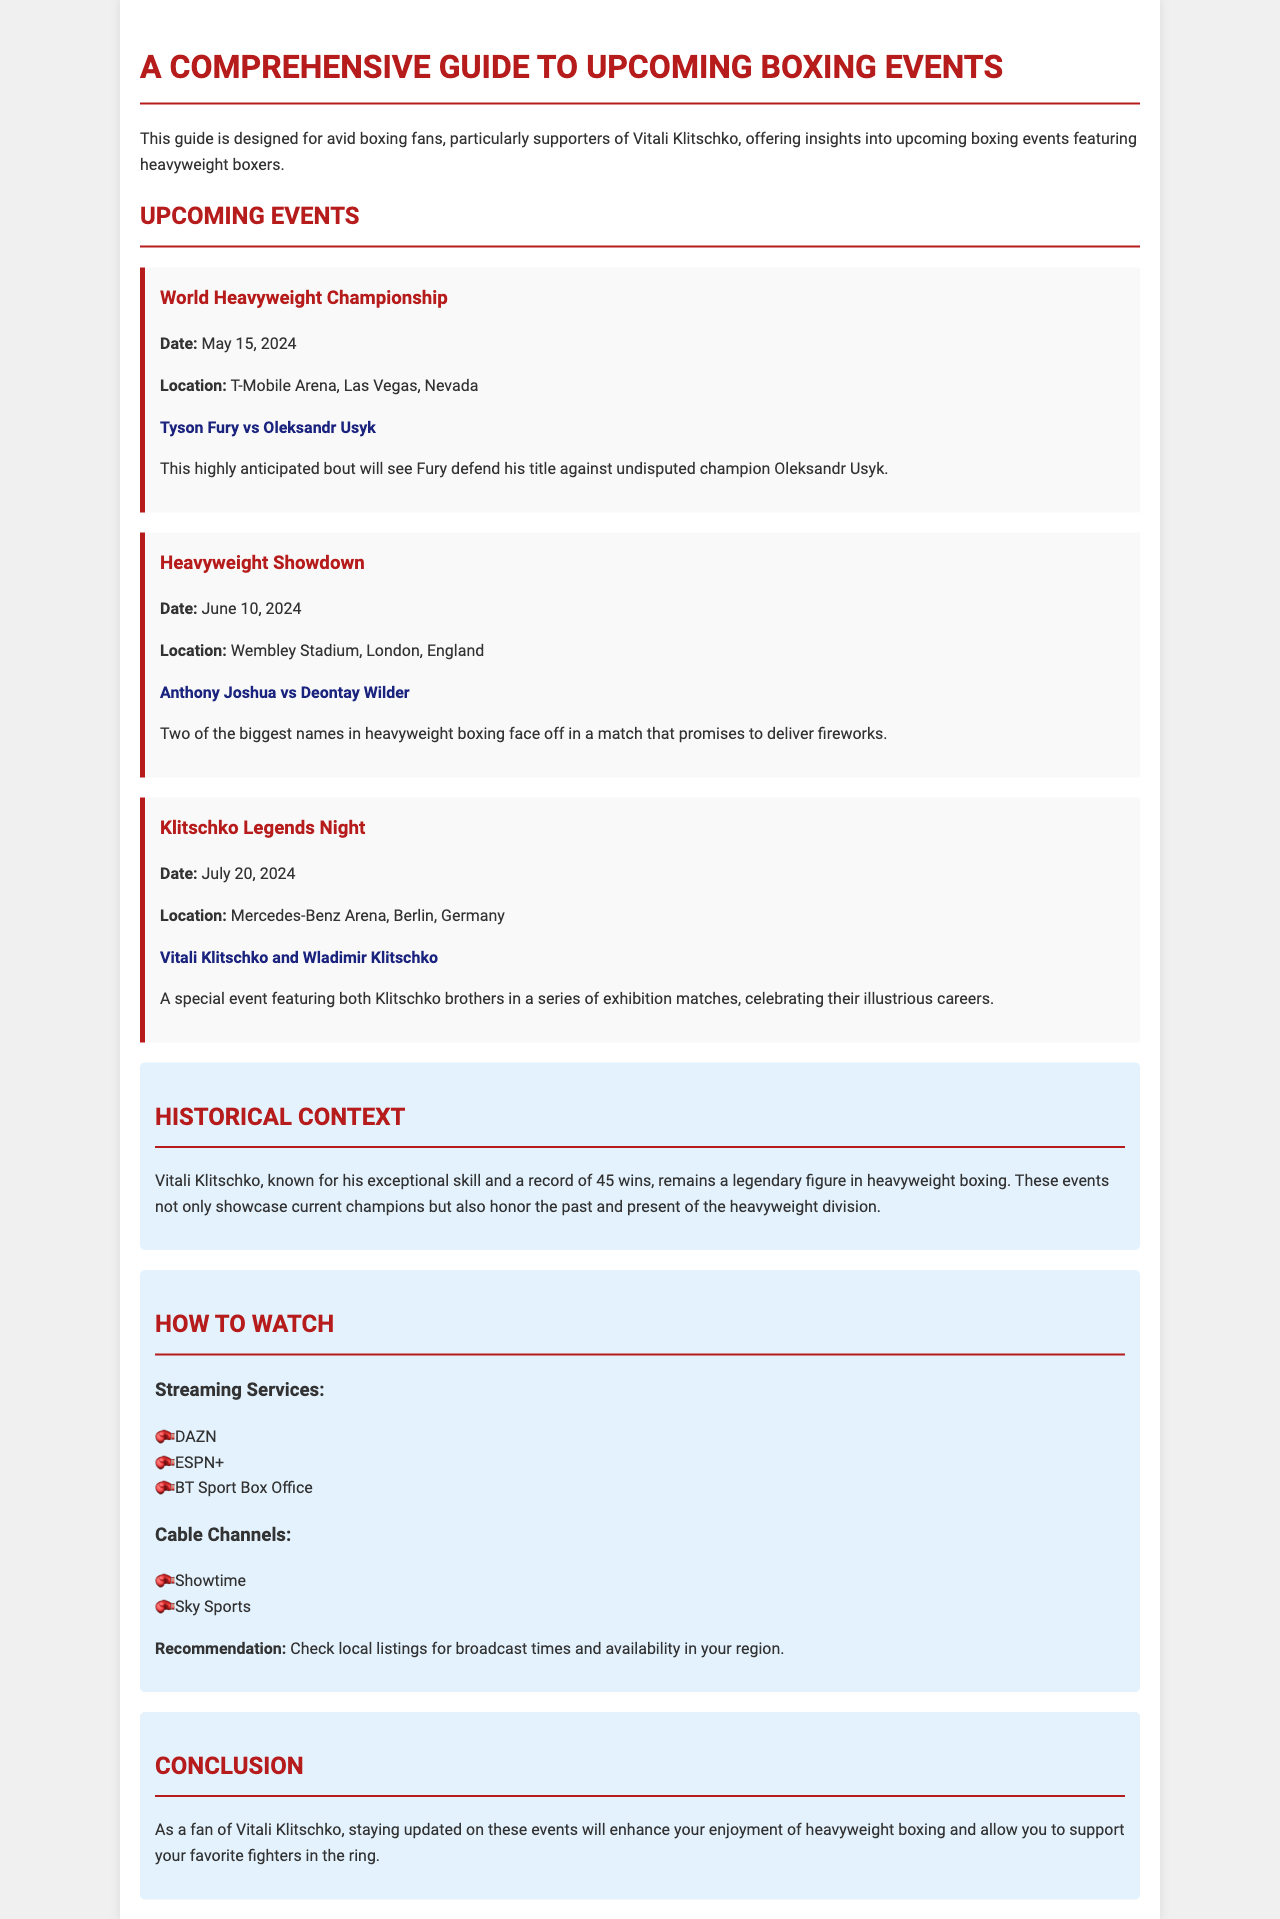What is the date of the World Heavyweight Championship? The date of the World Heavyweight Championship is stated in the upcoming events section of the document.
Answer: May 15, 2024 Where is the Heavyweight Showdown taking place? The location of the Heavyweight Showdown is mentioned in the event description.
Answer: Wembley Stadium, London, England Who are the fighters in the Klitschko Legends Night? The document lists the fighters in the Klitschko Legends Night event.
Answer: Vitali Klitschko and Wladimir Klitschko What is the purpose of the Klitschko Legends Night? The significance of the Klitschko Legends Night is explained in the context of honoring the fighters' careers.
Answer: Celebrating their illustrious careers Which streaming service is mentioned for watching the boxing events? The document provides a list of streaming services where the events can be watched.
Answer: DAZN What is the historical context provided about Vitali Klitschko? The historical context gives information about Vitali Klitschko's achievements as a boxer, indicating his legacy.
Answer: Legendary figure in heavyweight boxing How many total wins does Vitali Klitschko have according to the document? The document specifically states the number of wins in the historical context section.
Answer: 45 wins What recommendations does the document make regarding broadcast times? The recommendation section advises viewers on how to find broadcast times.
Answer: Check local listings 